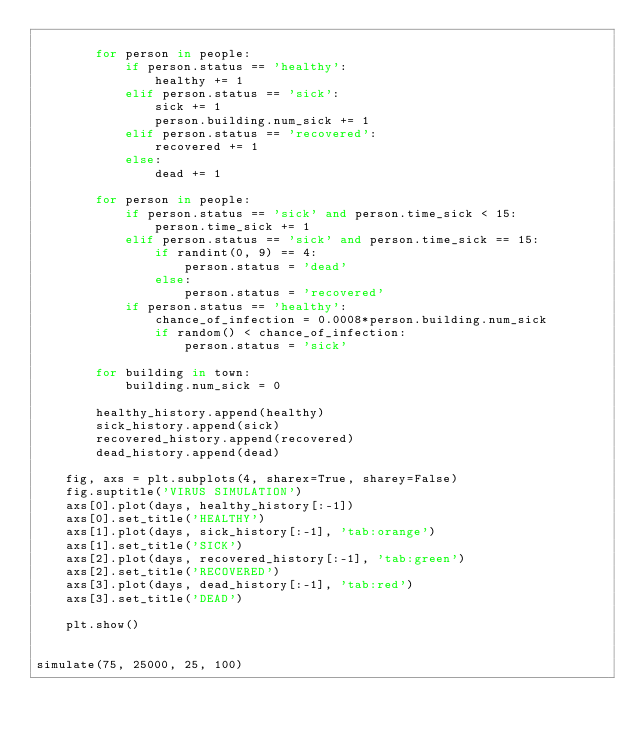Convert code to text. <code><loc_0><loc_0><loc_500><loc_500><_Python_>
        for person in people:
            if person.status == 'healthy':
                healthy += 1
            elif person.status == 'sick':
                sick += 1
                person.building.num_sick += 1
            elif person.status == 'recovered':
                recovered += 1
            else:
                dead += 1

        for person in people:
            if person.status == 'sick' and person.time_sick < 15:
                person.time_sick += 1
            elif person.status == 'sick' and person.time_sick == 15:
                if randint(0, 9) == 4:
                    person.status = 'dead'
                else:
                    person.status = 'recovered'
            if person.status == 'healthy':
                chance_of_infection = 0.0008*person.building.num_sick
                if random() < chance_of_infection:
                    person.status = 'sick'

        for building in town:
            building.num_sick = 0

        healthy_history.append(healthy)
        sick_history.append(sick)
        recovered_history.append(recovered)
        dead_history.append(dead)

    fig, axs = plt.subplots(4, sharex=True, sharey=False)
    fig.suptitle('VIRUS SIMULATION')
    axs[0].plot(days, healthy_history[:-1])
    axs[0].set_title('HEALTHY')
    axs[1].plot(days, sick_history[:-1], 'tab:orange')
    axs[1].set_title('SICK')
    axs[2].plot(days, recovered_history[:-1], 'tab:green')
    axs[2].set_title('RECOVERED')
    axs[3].plot(days, dead_history[:-1], 'tab:red')
    axs[3].set_title('DEAD')

    plt.show()


simulate(75, 25000, 25, 100)</code> 